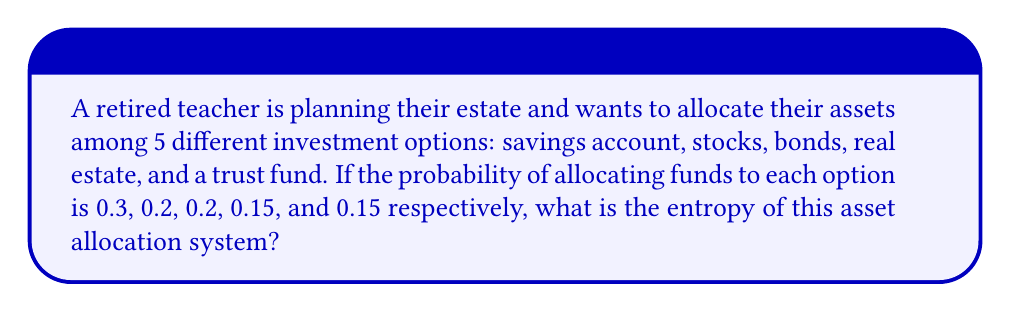Can you answer this question? To solve this problem, we'll use the concept of entropy from statistical mechanics, which can be applied to financial asset allocation. The entropy of a system is given by the formula:

$$S = -k_B \sum_{i=1}^{n} p_i \ln(p_i)$$

Where:
$S$ is the entropy
$k_B$ is Boltzmann's constant (which we'll set to 1 for simplicity in this financial context)
$p_i$ is the probability of the i-th state
$n$ is the number of possible states

Step 1: Identify the probabilities for each investment option:
$p_1 = 0.3$ (savings account)
$p_2 = 0.2$ (stocks)
$p_3 = 0.2$ (bonds)
$p_4 = 0.15$ (real estate)
$p_5 = 0.15$ (trust fund)

Step 2: Calculate $p_i \ln(p_i)$ for each option:
$0.3 \ln(0.3) = -0.3611$
$0.2 \ln(0.2) = -0.3219$
$0.2 \ln(0.2) = -0.3219$
$0.15 \ln(0.15) = -0.2849$
$0.15 \ln(0.15) = -0.2849$

Step 3: Sum up all the calculated values:
$\sum_{i=1}^{5} p_i \ln(p_i) = -0.3611 - 0.3219 - 0.3219 - 0.2849 - 0.2849 = -1.5747$

Step 4: Multiply the sum by -1 to get the entropy:
$S = -(-1.5747) = 1.5747$

Therefore, the entropy of the asset allocation system is approximately 1.5747.
Answer: $1.5747$ 